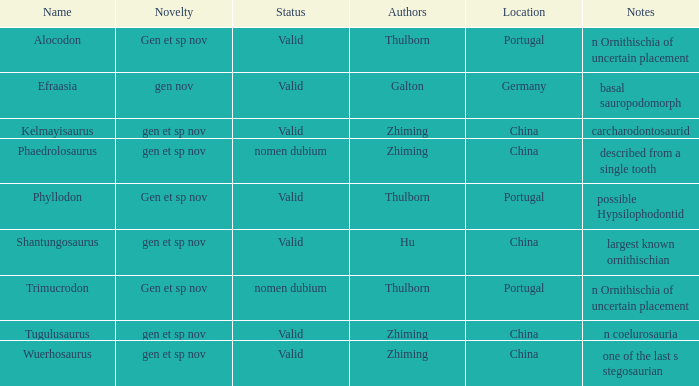What is the Name of the dinosaur, whose notes are, "n ornithischia of uncertain placement"? Alocodon, Trimucrodon. 